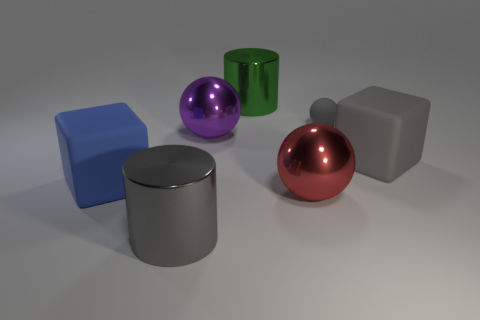Which objects in the image have shadows and what does that reveal about the light source? All objects in the image cast shadows on the surface beneath them. The shadows are soft-edged and oriented slightly to the left, which suggests that the light source is positioned to the right of the scene and above the objects, possibly indicating a single, diffuse light source like a softbox or window. 